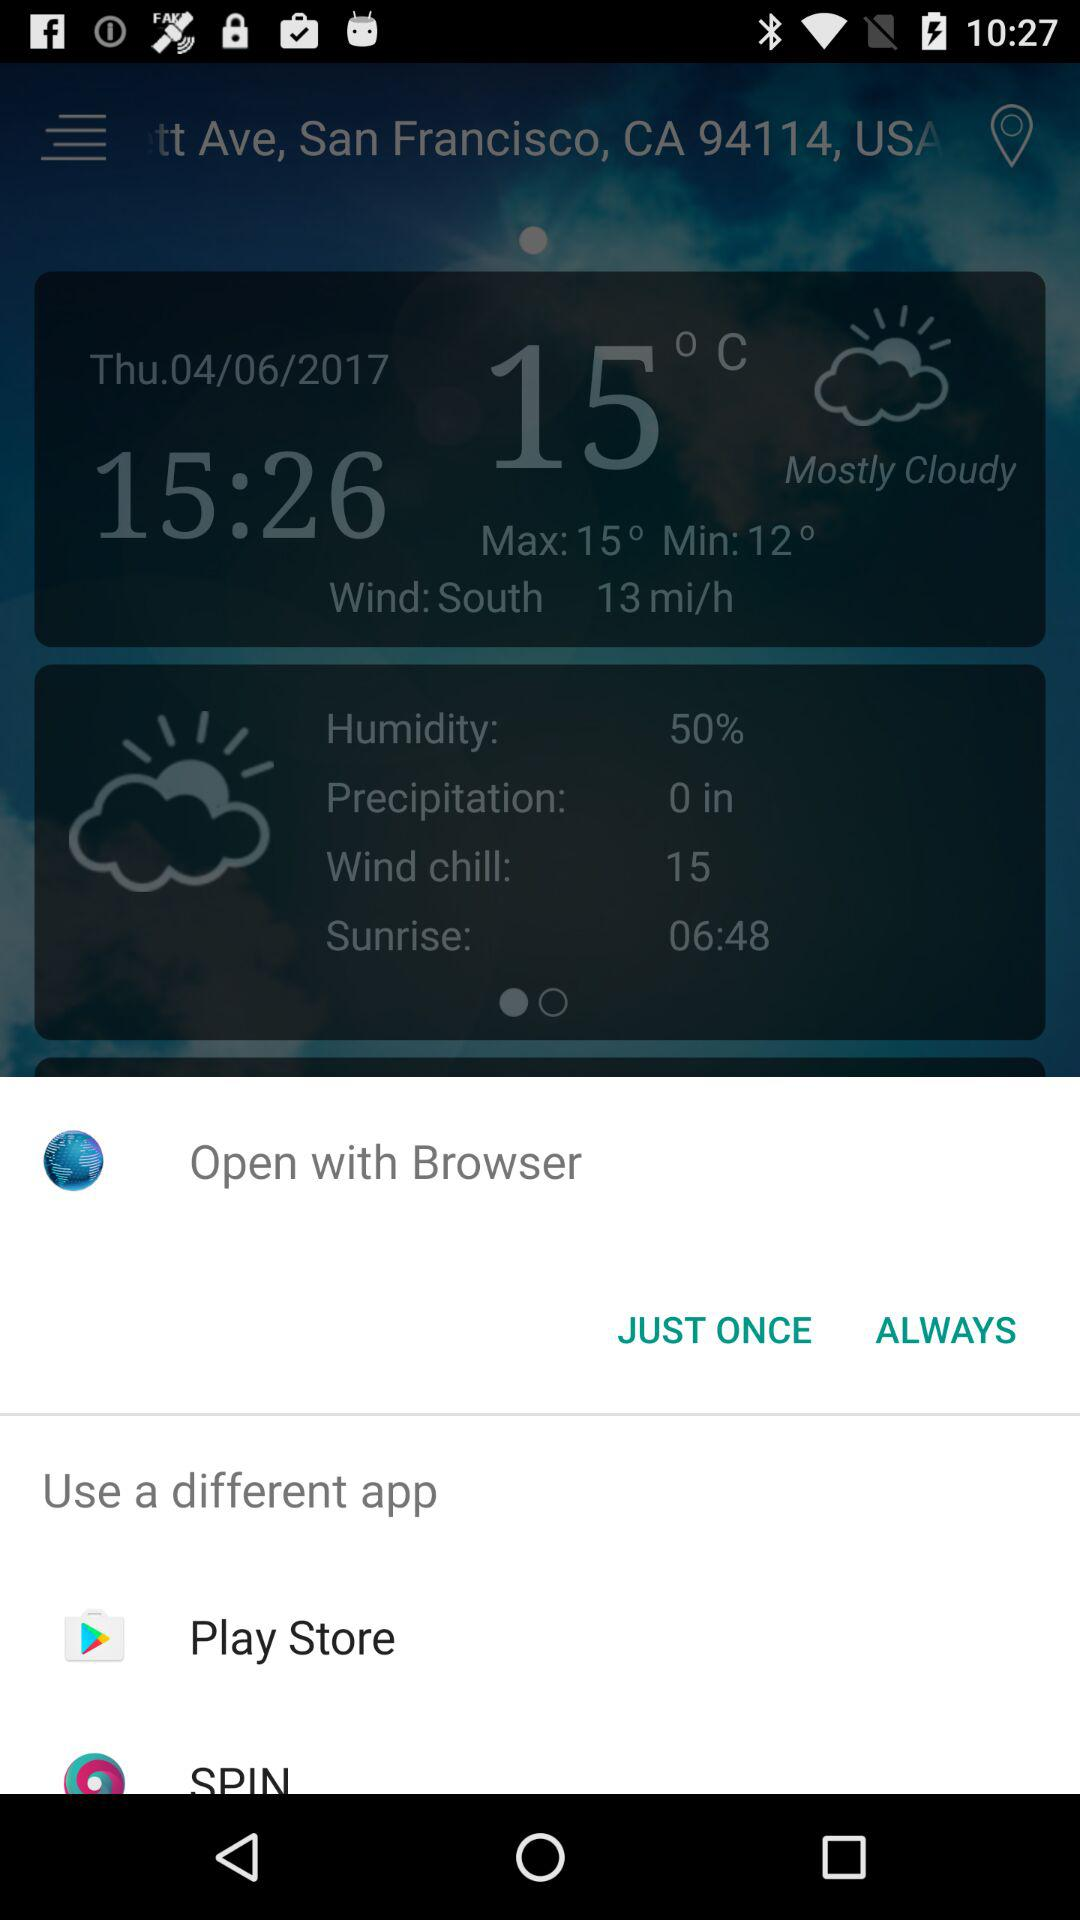What is the maximum temperature? The maximum temperature is 15 °C. 